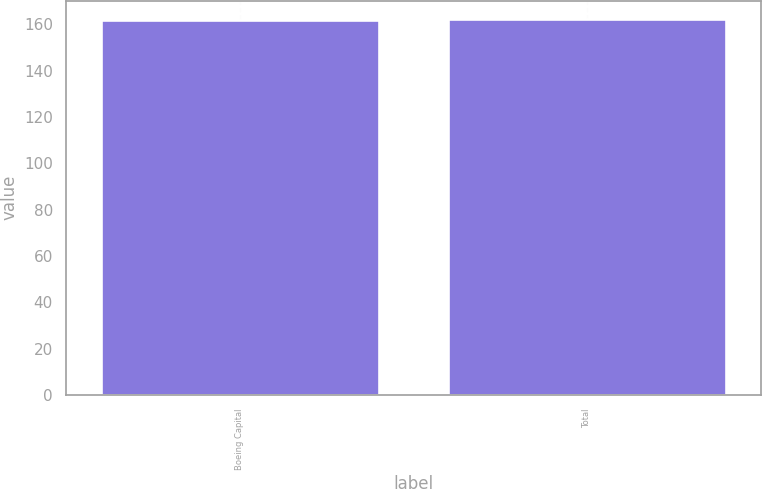<chart> <loc_0><loc_0><loc_500><loc_500><bar_chart><fcel>Boeing Capital<fcel>Total<nl><fcel>162<fcel>162.1<nl></chart> 